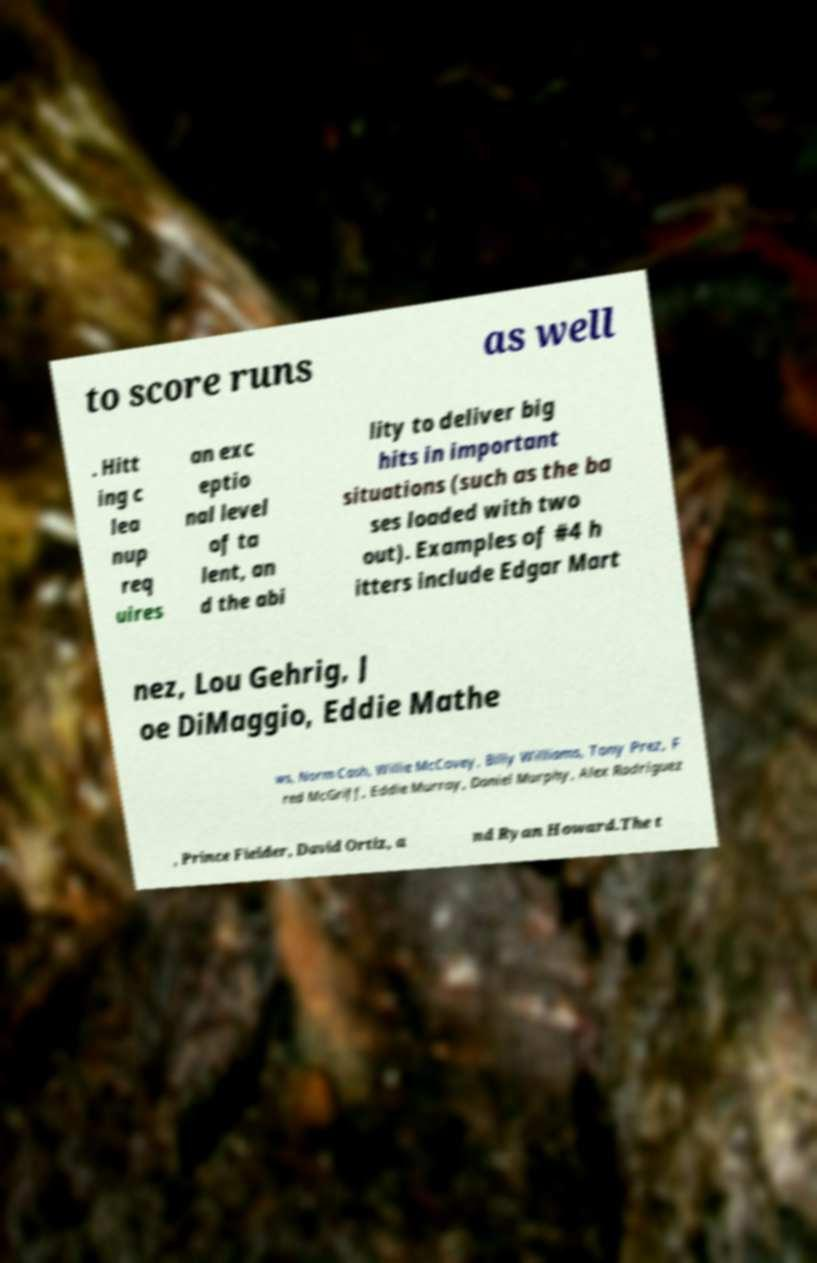There's text embedded in this image that I need extracted. Can you transcribe it verbatim? to score runs as well . Hitt ing c lea nup req uires an exc eptio nal level of ta lent, an d the abi lity to deliver big hits in important situations (such as the ba ses loaded with two out). Examples of #4 h itters include Edgar Mart nez, Lou Gehrig, J oe DiMaggio, Eddie Mathe ws, Norm Cash, Willie McCovey, Billy Williams, Tony Prez, F red McGriff, Eddie Murray, Daniel Murphy, Alex Rodriguez , Prince Fielder, David Ortiz, a nd Ryan Howard.The t 